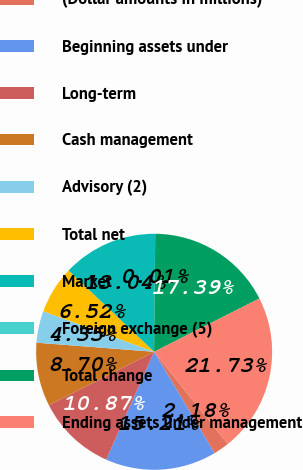Convert chart. <chart><loc_0><loc_0><loc_500><loc_500><pie_chart><fcel>(Dollar amounts in millions)<fcel>Beginning assets under<fcel>Long-term<fcel>Cash management<fcel>Advisory (2)<fcel>Total net<fcel>Market<fcel>Foreign exchange (5)<fcel>Total change<fcel>Ending assets under management<nl><fcel>2.18%<fcel>15.21%<fcel>10.87%<fcel>8.7%<fcel>4.35%<fcel>6.52%<fcel>13.04%<fcel>0.01%<fcel>17.39%<fcel>21.73%<nl></chart> 